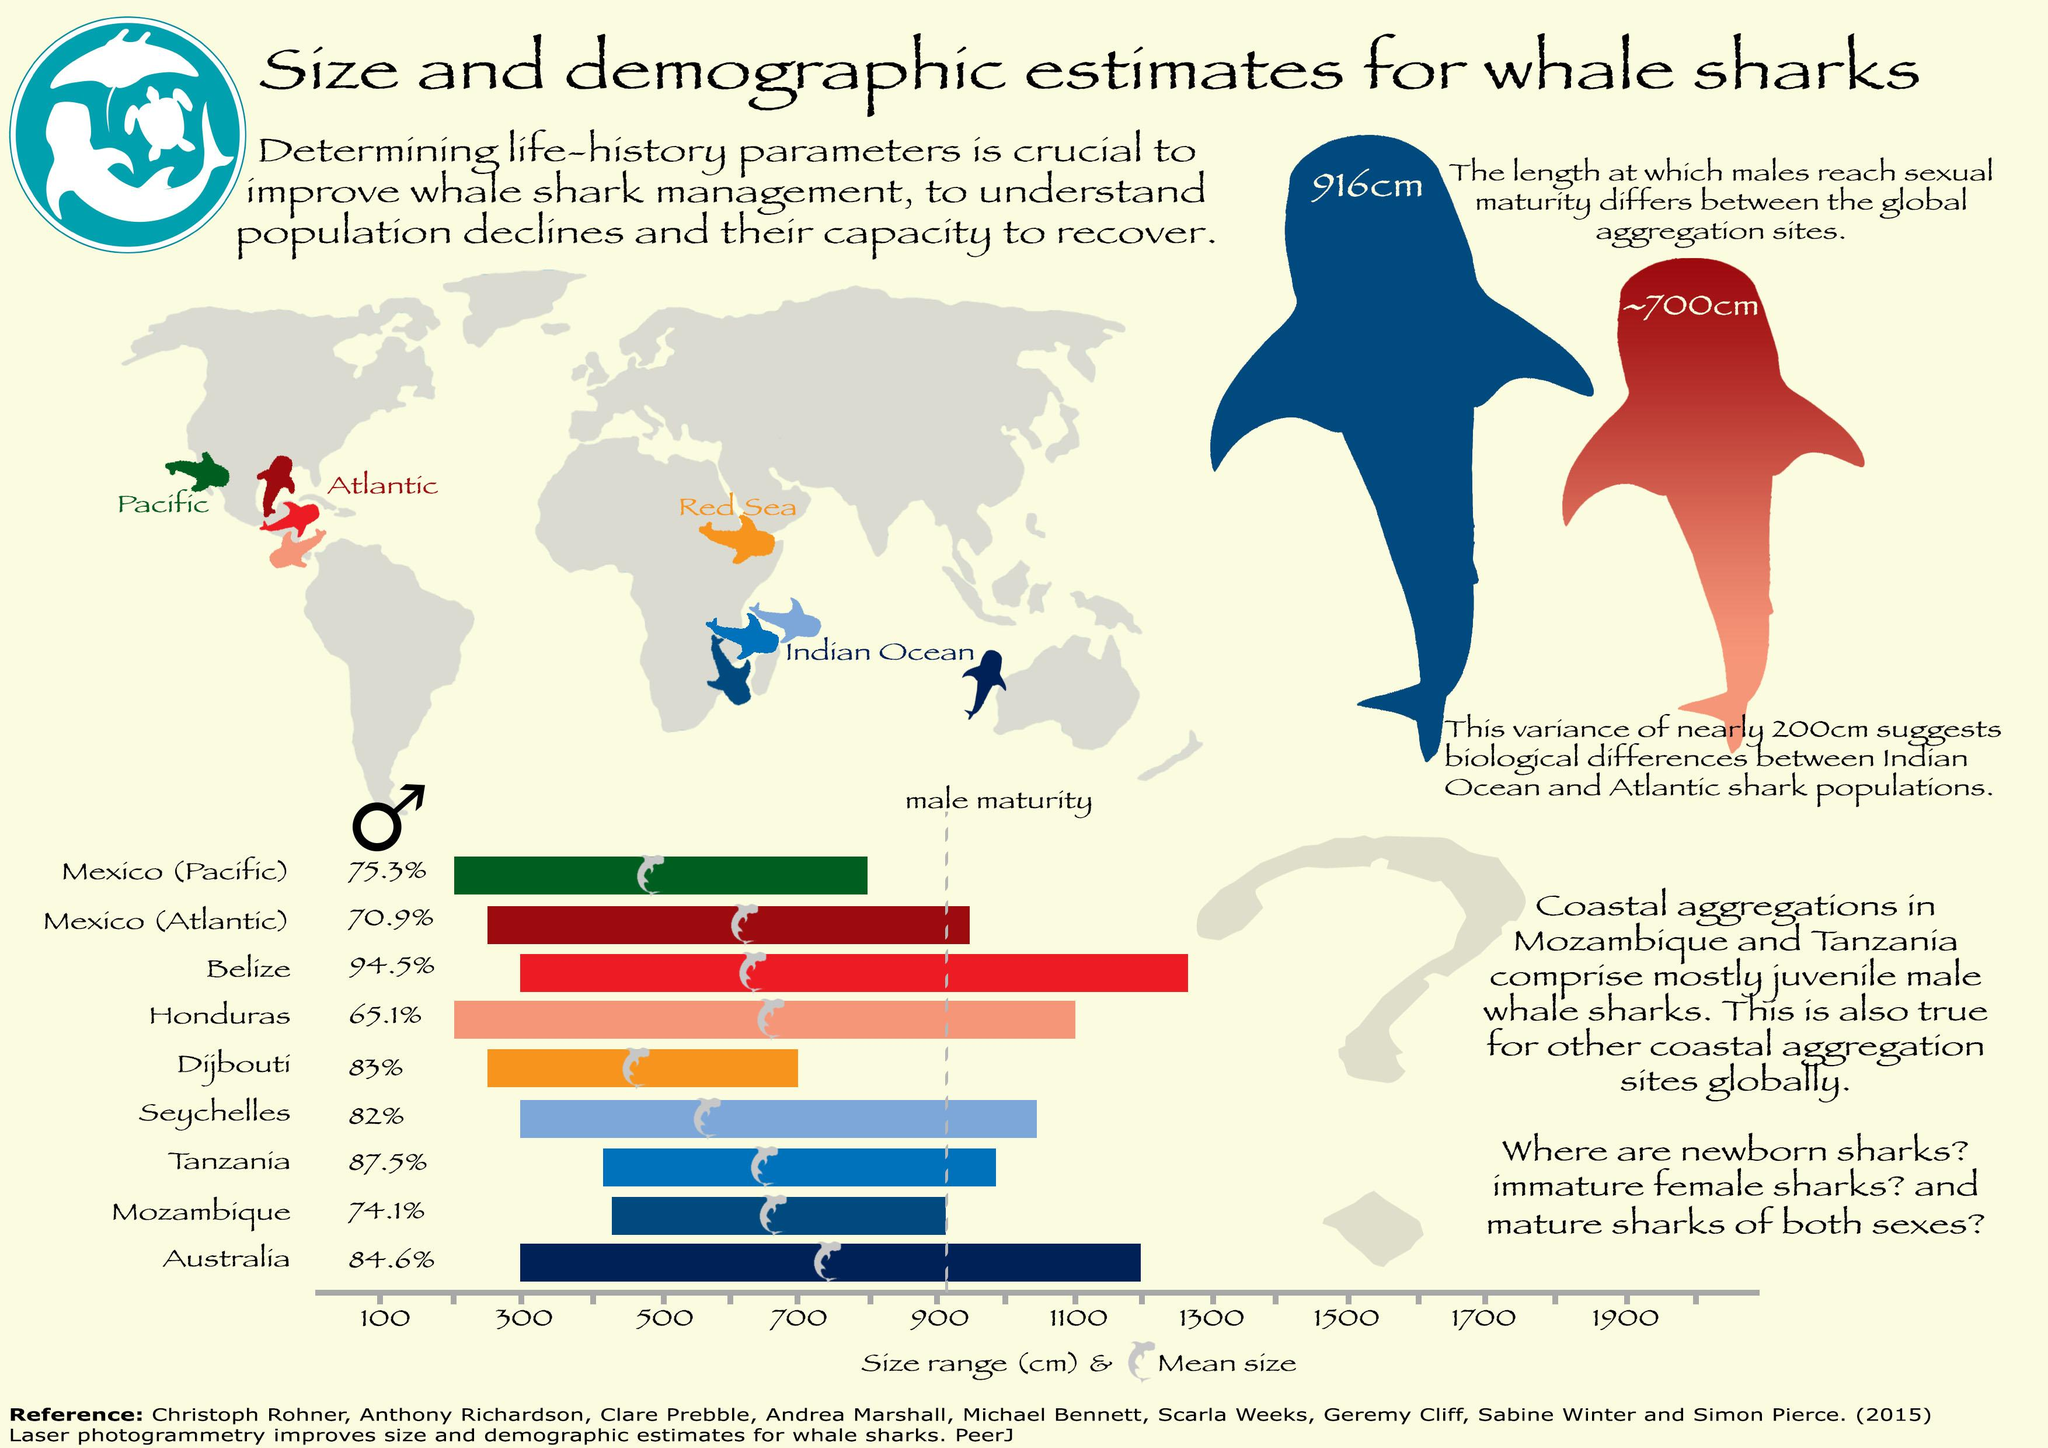Give some essential details in this illustration. The sexual maturity of whale sharks is reached at a length of 916 cm in the demographic area of the Indian Ocean. At a length of approximately 700 cm, Atlantic whale sharks typically reach sexual maturity. 